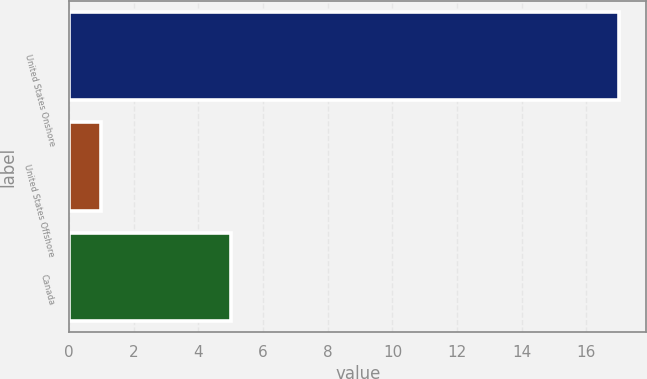Convert chart to OTSL. <chart><loc_0><loc_0><loc_500><loc_500><bar_chart><fcel>United States Onshore<fcel>United States Offshore<fcel>Canada<nl><fcel>17<fcel>1<fcel>5<nl></chart> 